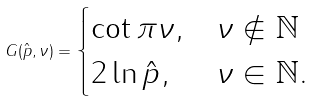Convert formula to latex. <formula><loc_0><loc_0><loc_500><loc_500>G ( \hat { p } , \nu ) = \begin{cases} \cot { \pi \nu } , & \nu \not \in { \mathbb { N } } \\ 2 \ln \hat { p } , & \nu \in { \mathbb { N } } . \end{cases}</formula> 